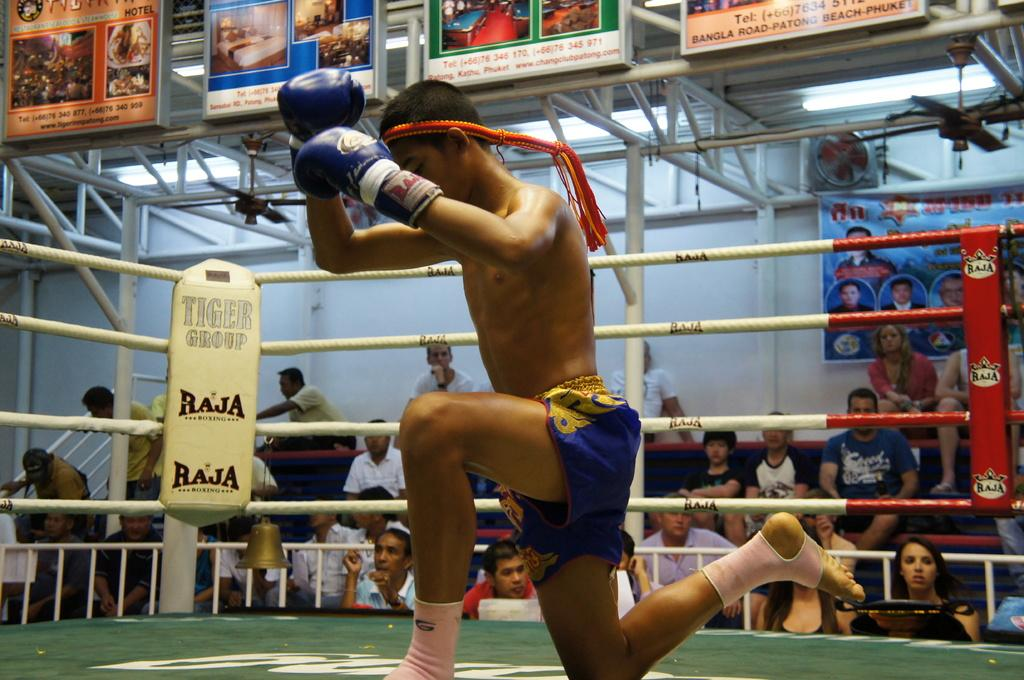<image>
Create a compact narrative representing the image presented. A man kneels down in a boxing ring for Raja. 